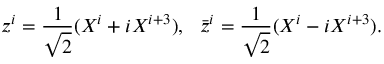<formula> <loc_0><loc_0><loc_500><loc_500>z ^ { i } = \frac { 1 } { \sqrt { 2 } } ( X ^ { i } + i X ^ { i + 3 } ) , \bar { z } ^ { i } = \frac { 1 } { \sqrt { 2 } } ( X ^ { i } - i X ^ { i + 3 } ) .</formula> 